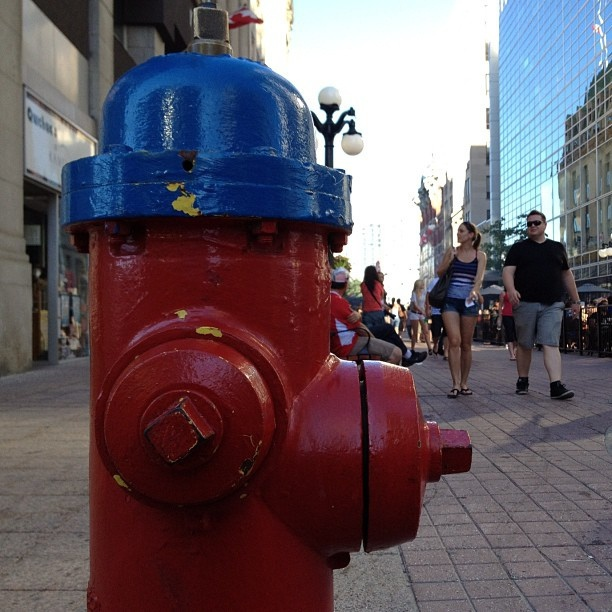Describe the objects in this image and their specific colors. I can see fire hydrant in gray, maroon, black, navy, and blue tones, people in gray and black tones, people in gray, black, maroon, and brown tones, people in gray, maroon, and black tones, and bench in gray, black, maroon, and purple tones in this image. 